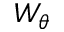<formula> <loc_0><loc_0><loc_500><loc_500>W _ { \theta }</formula> 